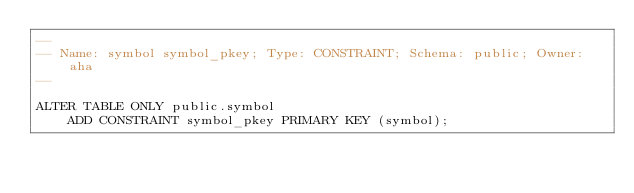<code> <loc_0><loc_0><loc_500><loc_500><_SQL_>--
-- Name: symbol symbol_pkey; Type: CONSTRAINT; Schema: public; Owner: aha
--

ALTER TABLE ONLY public.symbol
    ADD CONSTRAINT symbol_pkey PRIMARY KEY (symbol);


</code> 